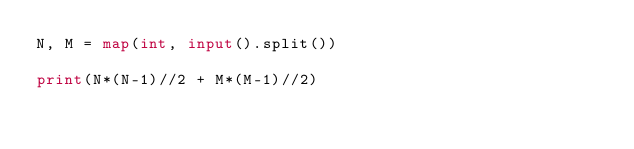Convert code to text. <code><loc_0><loc_0><loc_500><loc_500><_Python_>N, M = map(int, input().split())

print(N*(N-1)//2 + M*(M-1)//2)</code> 